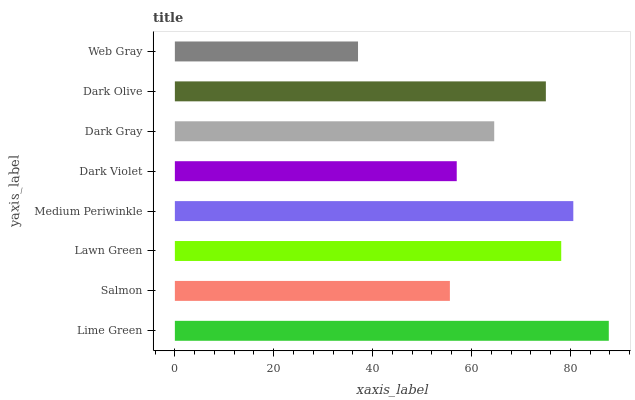Is Web Gray the minimum?
Answer yes or no. Yes. Is Lime Green the maximum?
Answer yes or no. Yes. Is Salmon the minimum?
Answer yes or no. No. Is Salmon the maximum?
Answer yes or no. No. Is Lime Green greater than Salmon?
Answer yes or no. Yes. Is Salmon less than Lime Green?
Answer yes or no. Yes. Is Salmon greater than Lime Green?
Answer yes or no. No. Is Lime Green less than Salmon?
Answer yes or no. No. Is Dark Olive the high median?
Answer yes or no. Yes. Is Dark Gray the low median?
Answer yes or no. Yes. Is Lawn Green the high median?
Answer yes or no. No. Is Web Gray the low median?
Answer yes or no. No. 